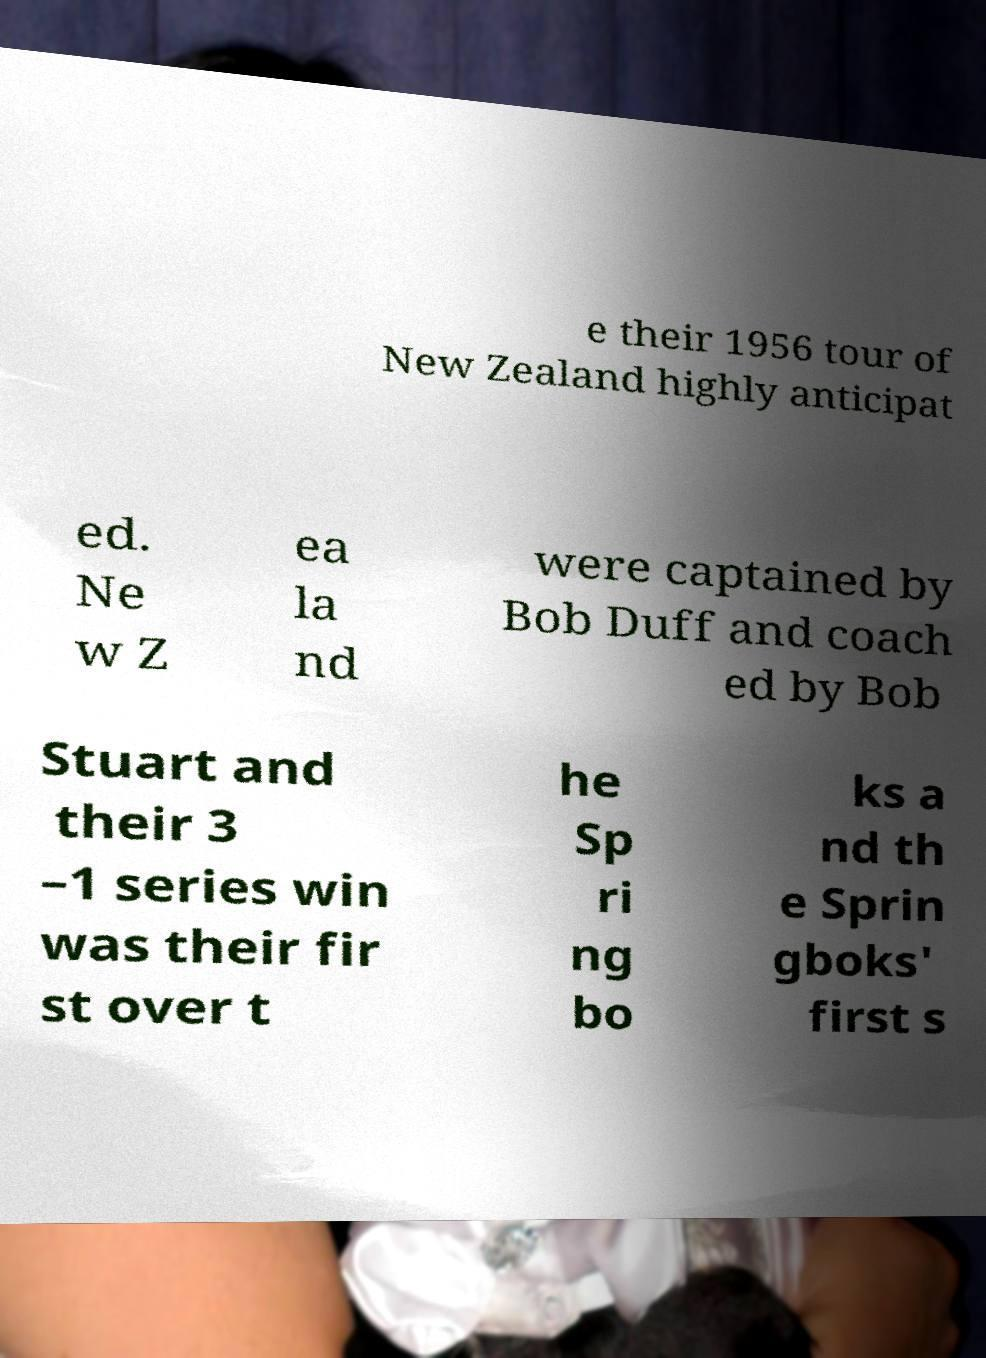Please read and relay the text visible in this image. What does it say? e their 1956 tour of New Zealand highly anticipat ed. Ne w Z ea la nd were captained by Bob Duff and coach ed by Bob Stuart and their 3 –1 series win was their fir st over t he Sp ri ng bo ks a nd th e Sprin gboks' first s 